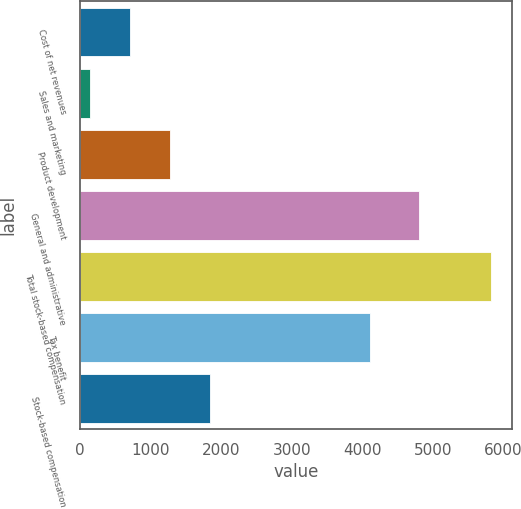Convert chart. <chart><loc_0><loc_0><loc_500><loc_500><bar_chart><fcel>Cost of net revenues<fcel>Sales and marketing<fcel>Product development<fcel>General and administrative<fcel>Total stock-based compensation<fcel>Tax benefit<fcel>Stock-based compensation<nl><fcel>705.6<fcel>136<fcel>1275.2<fcel>4809<fcel>5832<fcel>4117<fcel>1844.8<nl></chart> 